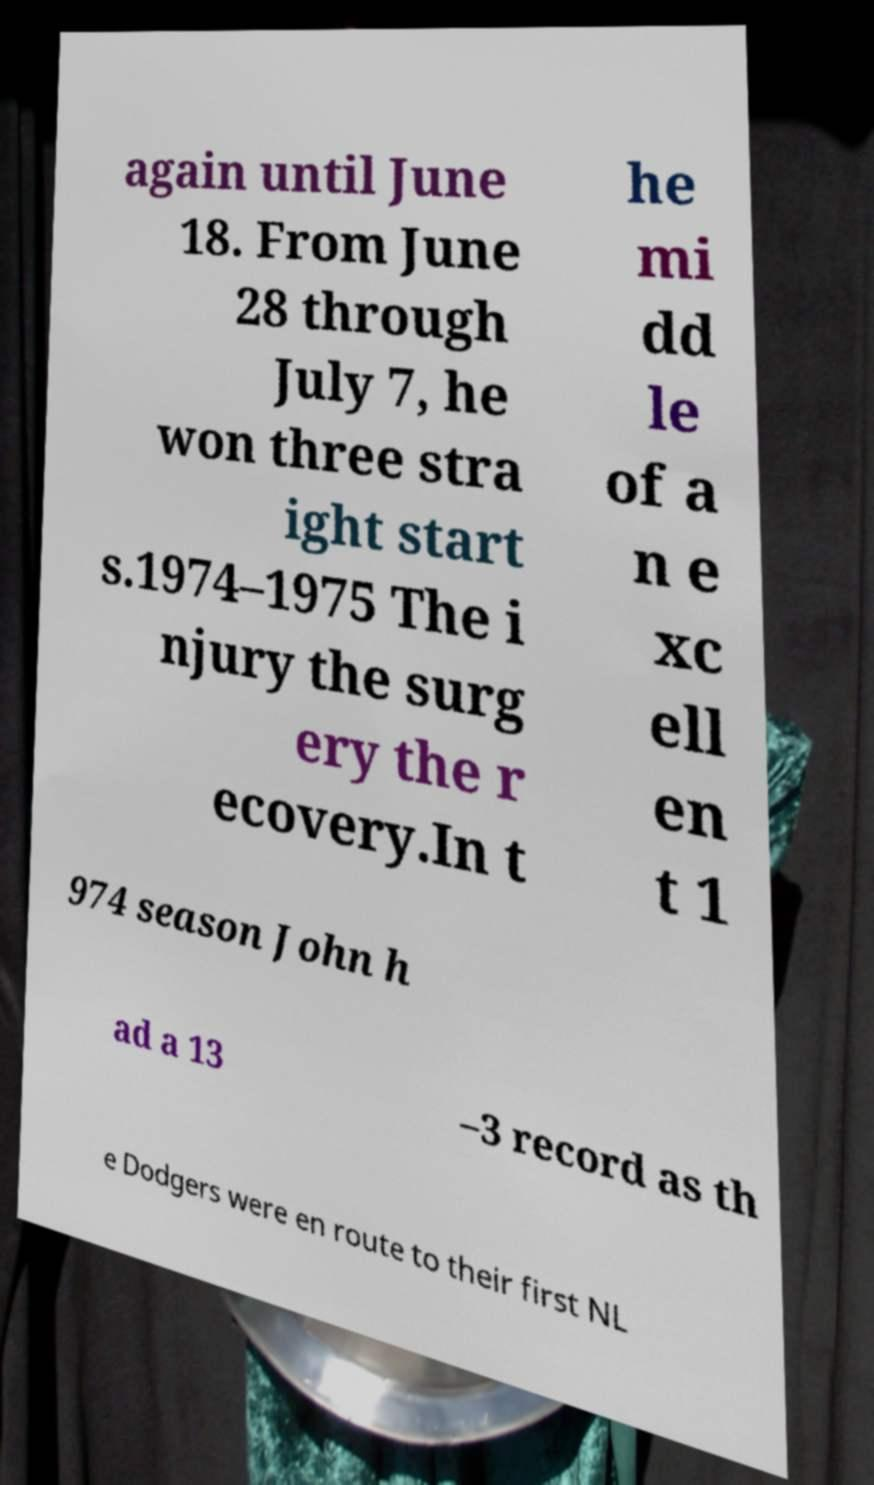I need the written content from this picture converted into text. Can you do that? again until June 18. From June 28 through July 7, he won three stra ight start s.1974–1975 The i njury the surg ery the r ecovery.In t he mi dd le of a n e xc ell en t 1 974 season John h ad a 13 –3 record as th e Dodgers were en route to their first NL 